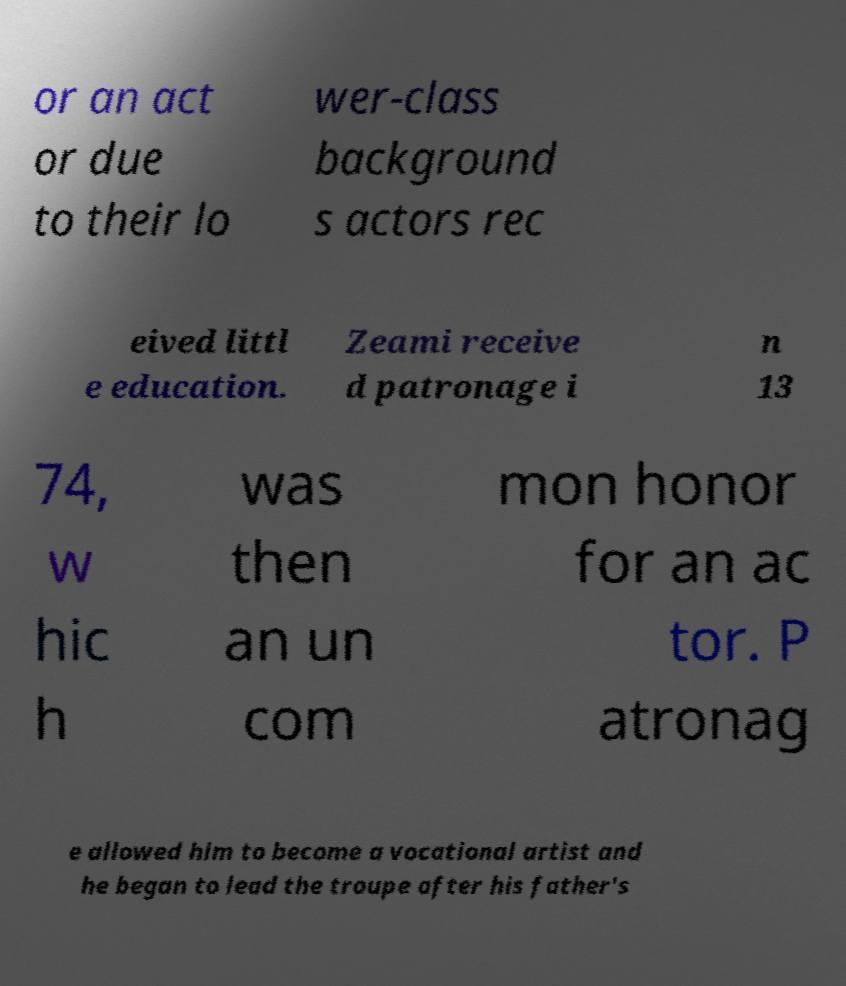What messages or text are displayed in this image? I need them in a readable, typed format. or an act or due to their lo wer-class background s actors rec eived littl e education. Zeami receive d patronage i n 13 74, w hic h was then an un com mon honor for an ac tor. P atronag e allowed him to become a vocational artist and he began to lead the troupe after his father's 